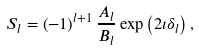Convert formula to latex. <formula><loc_0><loc_0><loc_500><loc_500>S _ { l } = \left ( - 1 \right ) ^ { l + 1 } \frac { A _ { l } } { B _ { l } } \exp \left ( 2 \imath \delta _ { l } \right ) ,</formula> 